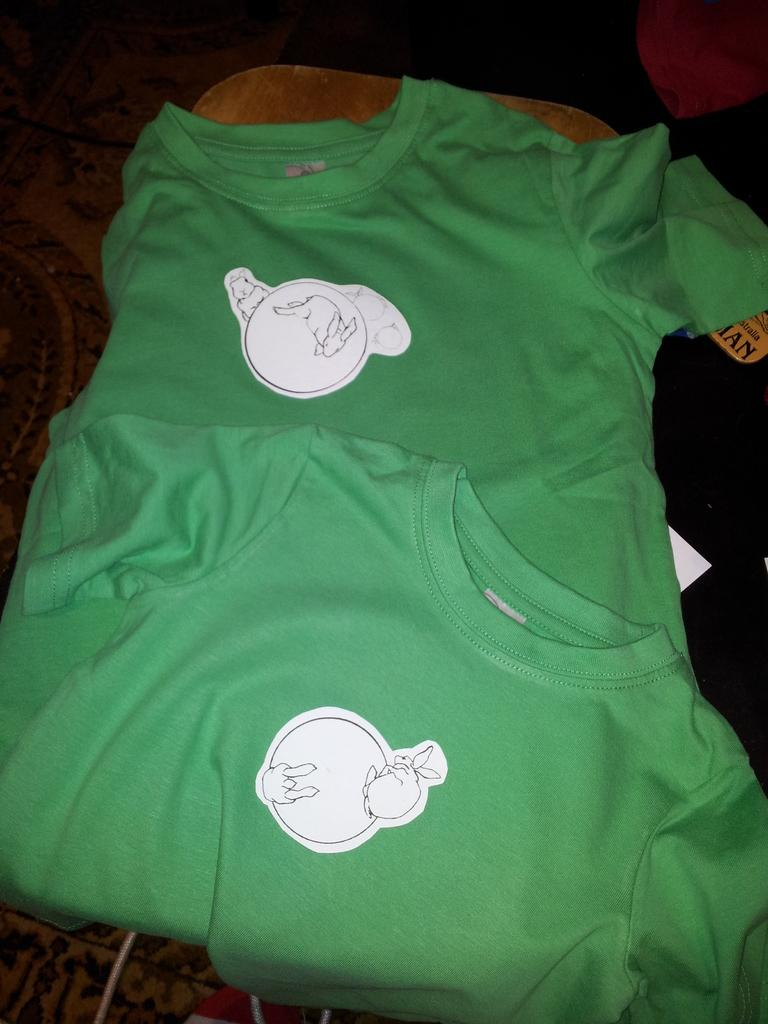What color are the t-shirts in the image? The t-shirts in the image are green. How many green t-shirts are there in the image? There are two green t-shirts in the image. What type of book is the maid reading in the hall while wearing the green t-shirts? There is no mention of a maid, reading, or hall in the image. The image only contains two green t-shirts. 